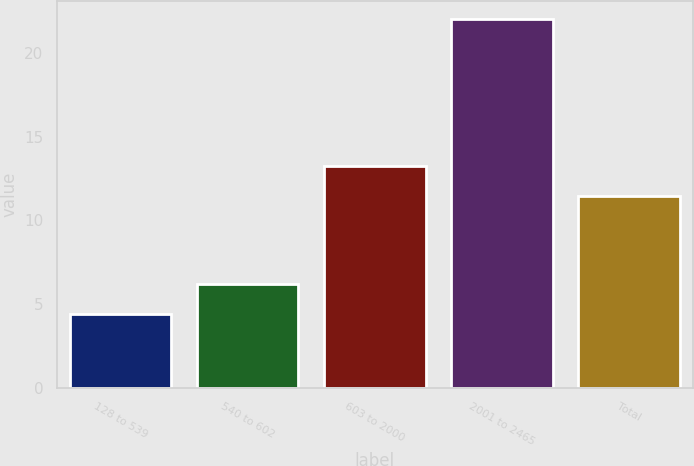Convert chart. <chart><loc_0><loc_0><loc_500><loc_500><bar_chart><fcel>128 to 539<fcel>540 to 602<fcel>603 to 2000<fcel>2001 to 2465<fcel>Total<nl><fcel>4.42<fcel>6.18<fcel>13.23<fcel>22.03<fcel>11.47<nl></chart> 